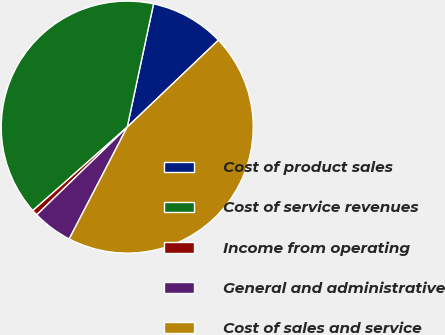Convert chart to OTSL. <chart><loc_0><loc_0><loc_500><loc_500><pie_chart><fcel>Cost of product sales<fcel>Cost of service revenues<fcel>Income from operating<fcel>General and administrative<fcel>Cost of sales and service<nl><fcel>9.53%<fcel>39.87%<fcel>0.73%<fcel>5.13%<fcel>44.74%<nl></chart> 